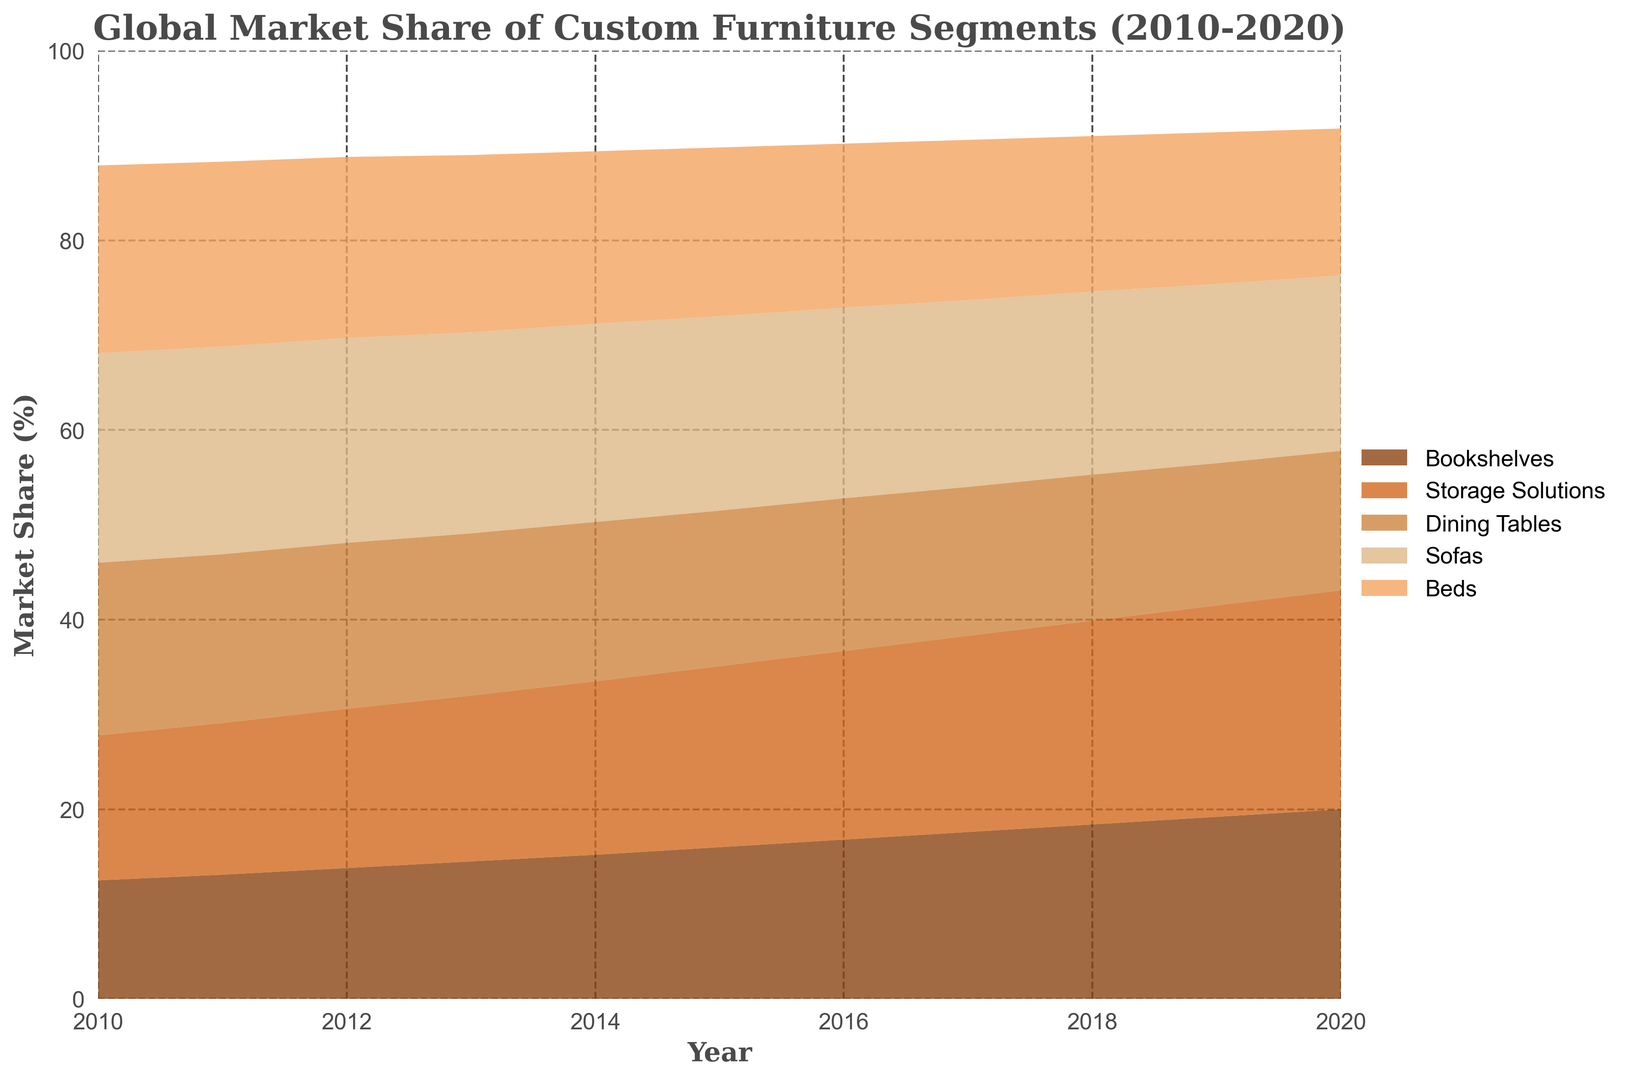What is the overall trend for the market share of bookshelves from 2010 to 2020? The trend for the market share of bookshelves can be observed as a continuous increase from 12.5% in 2010 to 20.0% in 2020. Plotting these values shows a rising slope, indicating that the demand or market share for bookshelves is growing over the years.
Answer: Continuous increase Which custom furniture segment had the highest market share in 2010? By observing the highest area at the start of the chart in 2010, Sofas had the largest market share with 22.1%.
Answer: Sofas How does the market share of storage solutions in 2015 compare to dining tables in the same year? In 2015, the market share for storage solutions is 19.1%, while for dining tables it is 16.4%. By comparing these values, storage solutions have a higher market share.
Answer: Storage solutions have a higher market share What is the difference in market share between bookshelves and beds in 2020? In 2020, the market share for bookshelves is 20.0%, and for beds, it is 15.5%. The difference is calculated by subtracting 15.5% from 20.0%, which is 4.5%.
Answer: 4.5% Which custom furniture segment showed the most growth in market share from 2010 to 2020? Observing the chart, storage solutions increased from 15.3% in 2010 to 23.1% in 2020. The growth can be calculated as 23.1% - 15.3% = 7.8%. This growth is more substantial compared to other segments, indicating storage solutions showed the most growth.
Answer: Storage Solutions How does the market share change for sofas from 2010 to 2020? The market share for sofas decreases from 22.1% in 2010 to 18.5% in 2020. This shows a downward trend over the decade.
Answer: Decreasing trend Which year did bookshelves surpass 18% market share for the first time? By examining the data points for bookshelves, it surpasses 18% in 2018 with a market share of 18.4%.
Answer: 2018 What is the sum of market share percentages for bookshelves and storage solutions in 2019? Adding the market shares for bookshelves (19.2%) and storage solutions (22.3%) in 2019 gives a total of 41.5%.
Answer: 41.5% Compare the market shares of dining tables and beds in 2013. Which one had a larger share? In 2013, the market share for dining tables is 17.1%, and for beds, it is 18.7%. Beds had a larger market share in that year.
Answer: Beds What visual color represents the data for sofas in the plot? By examining the legend of the plot, sofas are represented by a light brown or pale brown color.
Answer: Light brown 